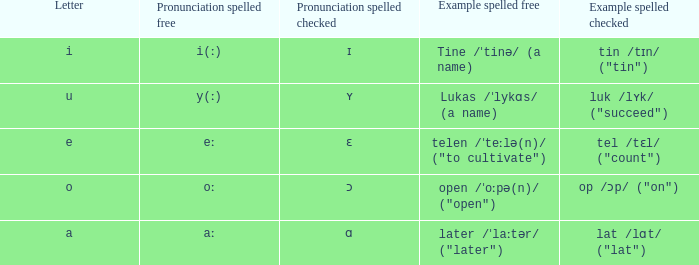What is Pronunciation Spelled Free, when Pronunciation Spelled Checked is "ɛ"? Eː. 